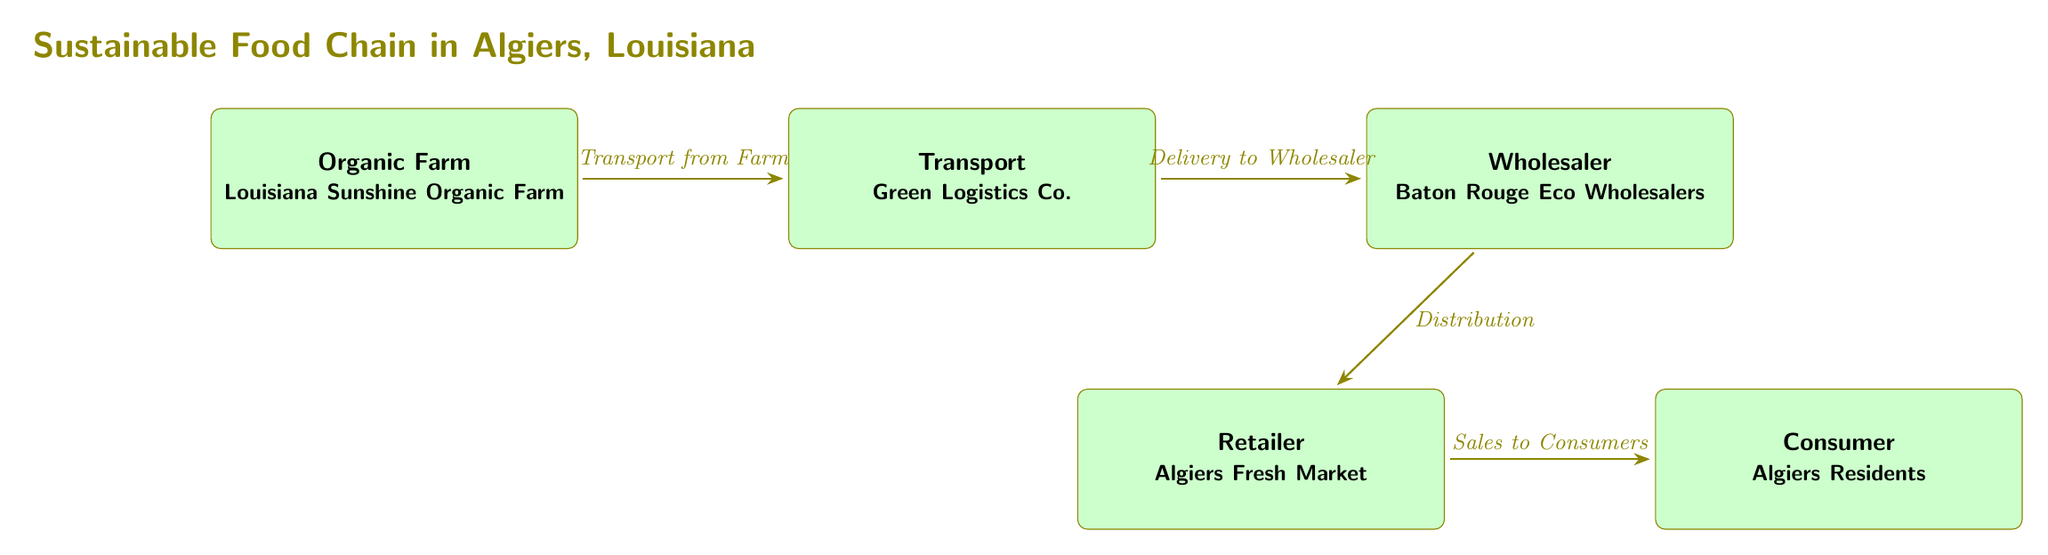What is the first node in the food chain? The first node in the food chain is the Organic Farm, indicating where the process begins with the production of organic goods.
Answer: Organic Farm How many nodes are present in the diagram? There are a total of five nodes in the diagram, which include the Organic Farm, Transport, Wholesaler, Retailer, and Consumer.
Answer: Five Who is the transport partner in the diagram? The transport partner in the diagram is Green Logistics Co., responsible for moving goods from the farm to the wholesaler.
Answer: Green Logistics Co What is the role of Baton Rouge Eco Wholesalers? Baton Rouge Eco Wholesalers serves as the wholesaler in the food chain, distributing goods to retailers after receiving them from the transport partner.
Answer: Wholesaler What type of market is Algiers Fresh Market? Algiers Fresh Market is identified as the retailer in the diagram, indicating its role in selling products directly to consumers.
Answer: Retailer Describe the flow from the Organic Farm to the Consumer. The flow starts with the Organic Farm producing organic goods, which are then transported by Green Logistics Co. to Baton Rouge Eco Wholesalers for distribution. Once the goods reach Algiers Fresh Market (the retailer), they are sold to the consumers, who are the final node in the food chain.
Answer: Organic Farm → Transport → Wholesaler → Retailer → Consumer Which node connects directly to the Consumer? The Retailer connects directly to the Consumer, facilitating the sale of goods to the people in Algiers.
Answer: Retailer What type of practices does the food chain emphasize? The food chain emphasizes sustainability practices, focusing on organic farming and environmentally friendly logistics in Algiers, Louisiana.
Answer: Sustainability practices What is the sequence of delivery in the diagram? The sequence of delivery begins with transport from the Organic Farm to the Wholesaler, followed by distribution to the Retailer, and concludes with sales to the Consumer.
Answer: Transport → Wholesaler → Retailer → Consumer 